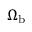Convert formula to latex. <formula><loc_0><loc_0><loc_500><loc_500>\Omega _ { b }</formula> 